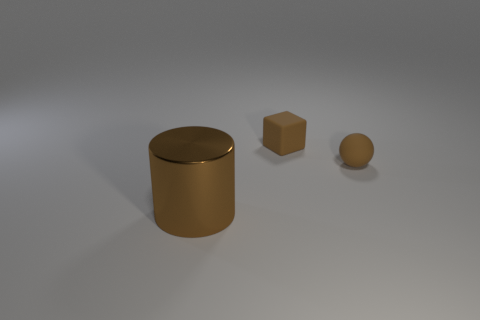Add 1 large yellow things. How many objects exist? 4 Subtract all blocks. How many objects are left? 2 Subtract 0 purple cylinders. How many objects are left? 3 Subtract all brown metallic objects. Subtract all balls. How many objects are left? 1 Add 3 big metallic things. How many big metallic things are left? 4 Add 1 metal things. How many metal things exist? 2 